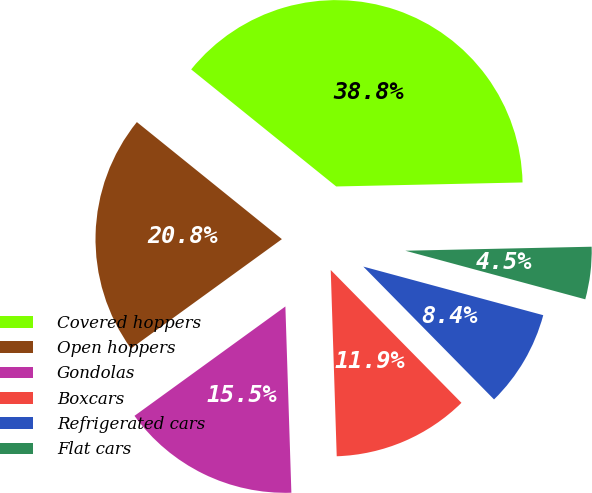Convert chart to OTSL. <chart><loc_0><loc_0><loc_500><loc_500><pie_chart><fcel>Covered hoppers<fcel>Open hoppers<fcel>Gondolas<fcel>Boxcars<fcel>Refrigerated cars<fcel>Flat cars<nl><fcel>38.85%<fcel>20.79%<fcel>15.53%<fcel>11.86%<fcel>8.43%<fcel>4.54%<nl></chart> 